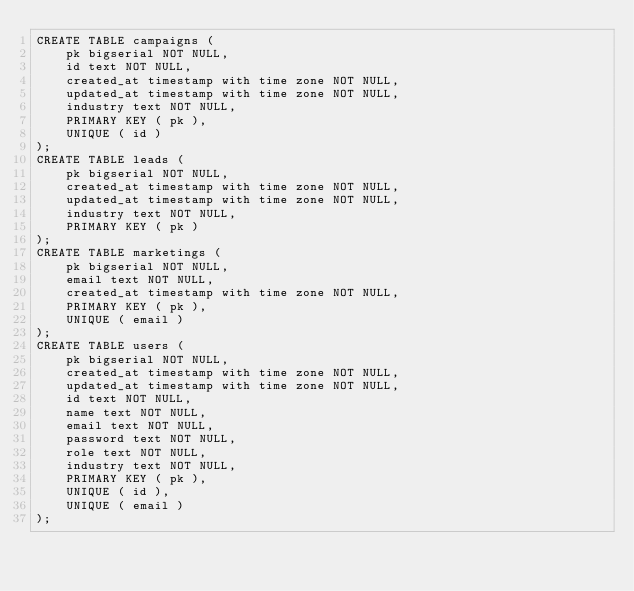Convert code to text. <code><loc_0><loc_0><loc_500><loc_500><_SQL_>CREATE TABLE campaigns (
	pk bigserial NOT NULL,
	id text NOT NULL,
	created_at timestamp with time zone NOT NULL,
	updated_at timestamp with time zone NOT NULL,
	industry text NOT NULL,
	PRIMARY KEY ( pk ),
	UNIQUE ( id )
);
CREATE TABLE leads (
	pk bigserial NOT NULL,
	created_at timestamp with time zone NOT NULL,
	updated_at timestamp with time zone NOT NULL,
	industry text NOT NULL,
	PRIMARY KEY ( pk )
);
CREATE TABLE marketings (
	pk bigserial NOT NULL,
	email text NOT NULL,
	created_at timestamp with time zone NOT NULL,
	PRIMARY KEY ( pk ),
	UNIQUE ( email )
);
CREATE TABLE users (
	pk bigserial NOT NULL,
	created_at timestamp with time zone NOT NULL,
	updated_at timestamp with time zone NOT NULL,
	id text NOT NULL,
	name text NOT NULL,
	email text NOT NULL,
	password text NOT NULL,
	role text NOT NULL,
	industry text NOT NULL,
	PRIMARY KEY ( pk ),
	UNIQUE ( id ),
	UNIQUE ( email )
);
</code> 